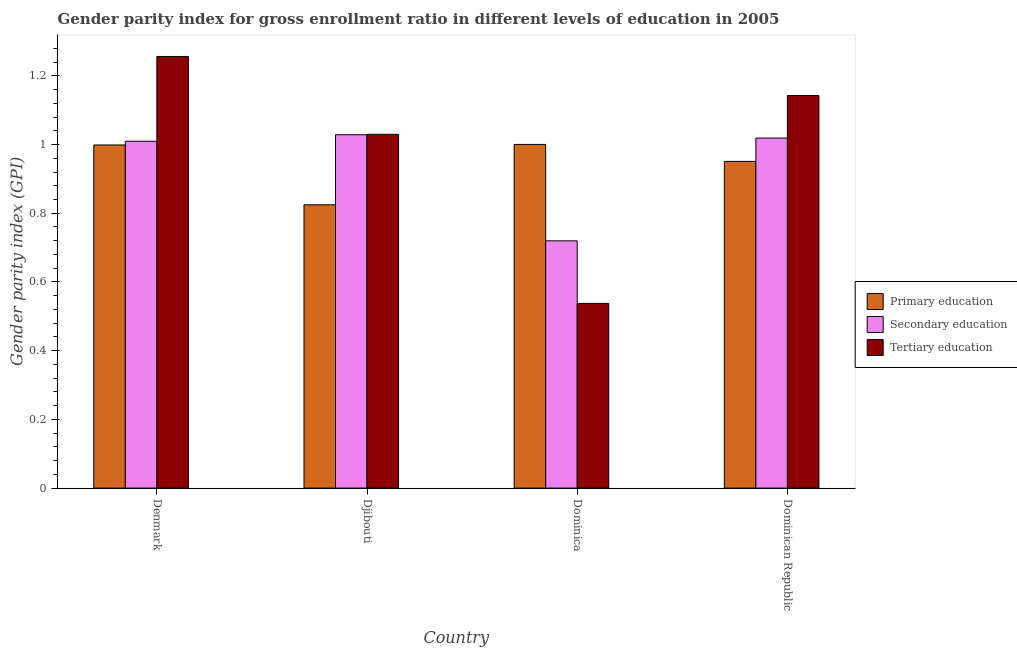How many different coloured bars are there?
Your response must be concise. 3. What is the label of the 3rd group of bars from the left?
Provide a short and direct response. Dominica. What is the gender parity index in tertiary education in Dominica?
Your answer should be very brief. 0.54. Across all countries, what is the maximum gender parity index in primary education?
Give a very brief answer. 1. Across all countries, what is the minimum gender parity index in secondary education?
Offer a terse response. 0.72. In which country was the gender parity index in tertiary education maximum?
Give a very brief answer. Denmark. In which country was the gender parity index in secondary education minimum?
Your answer should be compact. Dominica. What is the total gender parity index in tertiary education in the graph?
Offer a terse response. 3.97. What is the difference between the gender parity index in tertiary education in Dominica and that in Dominican Republic?
Keep it short and to the point. -0.61. What is the difference between the gender parity index in primary education in Djibouti and the gender parity index in tertiary education in Dominican Republic?
Ensure brevity in your answer.  -0.32. What is the average gender parity index in tertiary education per country?
Keep it short and to the point. 0.99. What is the difference between the gender parity index in primary education and gender parity index in tertiary education in Djibouti?
Keep it short and to the point. -0.21. What is the ratio of the gender parity index in primary education in Djibouti to that in Dominican Republic?
Offer a very short reply. 0.87. Is the gender parity index in primary education in Denmark less than that in Djibouti?
Your answer should be very brief. No. What is the difference between the highest and the second highest gender parity index in tertiary education?
Make the answer very short. 0.11. What is the difference between the highest and the lowest gender parity index in tertiary education?
Provide a succinct answer. 0.72. Is the sum of the gender parity index in primary education in Denmark and Djibouti greater than the maximum gender parity index in tertiary education across all countries?
Your answer should be very brief. Yes. What does the 1st bar from the left in Dominica represents?
Your answer should be compact. Primary education. Is it the case that in every country, the sum of the gender parity index in primary education and gender parity index in secondary education is greater than the gender parity index in tertiary education?
Your answer should be compact. Yes. Are all the bars in the graph horizontal?
Provide a succinct answer. No. How many countries are there in the graph?
Provide a succinct answer. 4. How are the legend labels stacked?
Provide a short and direct response. Vertical. What is the title of the graph?
Offer a terse response. Gender parity index for gross enrollment ratio in different levels of education in 2005. Does "Unpaid family workers" appear as one of the legend labels in the graph?
Your response must be concise. No. What is the label or title of the X-axis?
Your answer should be compact. Country. What is the label or title of the Y-axis?
Give a very brief answer. Gender parity index (GPI). What is the Gender parity index (GPI) of Primary education in Denmark?
Ensure brevity in your answer.  1. What is the Gender parity index (GPI) of Secondary education in Denmark?
Your answer should be very brief. 1.01. What is the Gender parity index (GPI) in Tertiary education in Denmark?
Your response must be concise. 1.26. What is the Gender parity index (GPI) in Primary education in Djibouti?
Your answer should be very brief. 0.82. What is the Gender parity index (GPI) of Secondary education in Djibouti?
Provide a short and direct response. 1.03. What is the Gender parity index (GPI) of Tertiary education in Djibouti?
Offer a terse response. 1.03. What is the Gender parity index (GPI) of Primary education in Dominica?
Keep it short and to the point. 1. What is the Gender parity index (GPI) of Secondary education in Dominica?
Keep it short and to the point. 0.72. What is the Gender parity index (GPI) in Tertiary education in Dominica?
Offer a very short reply. 0.54. What is the Gender parity index (GPI) of Primary education in Dominican Republic?
Make the answer very short. 0.95. What is the Gender parity index (GPI) of Secondary education in Dominican Republic?
Ensure brevity in your answer.  1.02. What is the Gender parity index (GPI) of Tertiary education in Dominican Republic?
Provide a succinct answer. 1.14. Across all countries, what is the maximum Gender parity index (GPI) in Primary education?
Offer a very short reply. 1. Across all countries, what is the maximum Gender parity index (GPI) in Secondary education?
Your answer should be compact. 1.03. Across all countries, what is the maximum Gender parity index (GPI) of Tertiary education?
Provide a succinct answer. 1.26. Across all countries, what is the minimum Gender parity index (GPI) of Primary education?
Provide a short and direct response. 0.82. Across all countries, what is the minimum Gender parity index (GPI) in Secondary education?
Make the answer very short. 0.72. Across all countries, what is the minimum Gender parity index (GPI) of Tertiary education?
Ensure brevity in your answer.  0.54. What is the total Gender parity index (GPI) in Primary education in the graph?
Provide a succinct answer. 3.77. What is the total Gender parity index (GPI) in Secondary education in the graph?
Keep it short and to the point. 3.78. What is the total Gender parity index (GPI) in Tertiary education in the graph?
Keep it short and to the point. 3.97. What is the difference between the Gender parity index (GPI) of Primary education in Denmark and that in Djibouti?
Ensure brevity in your answer.  0.17. What is the difference between the Gender parity index (GPI) of Secondary education in Denmark and that in Djibouti?
Your answer should be very brief. -0.02. What is the difference between the Gender parity index (GPI) of Tertiary education in Denmark and that in Djibouti?
Make the answer very short. 0.23. What is the difference between the Gender parity index (GPI) of Primary education in Denmark and that in Dominica?
Your response must be concise. -0. What is the difference between the Gender parity index (GPI) in Secondary education in Denmark and that in Dominica?
Ensure brevity in your answer.  0.29. What is the difference between the Gender parity index (GPI) of Tertiary education in Denmark and that in Dominica?
Give a very brief answer. 0.72. What is the difference between the Gender parity index (GPI) of Primary education in Denmark and that in Dominican Republic?
Your answer should be very brief. 0.05. What is the difference between the Gender parity index (GPI) of Secondary education in Denmark and that in Dominican Republic?
Give a very brief answer. -0.01. What is the difference between the Gender parity index (GPI) of Tertiary education in Denmark and that in Dominican Republic?
Ensure brevity in your answer.  0.11. What is the difference between the Gender parity index (GPI) in Primary education in Djibouti and that in Dominica?
Keep it short and to the point. -0.18. What is the difference between the Gender parity index (GPI) of Secondary education in Djibouti and that in Dominica?
Provide a succinct answer. 0.31. What is the difference between the Gender parity index (GPI) of Tertiary education in Djibouti and that in Dominica?
Offer a very short reply. 0.49. What is the difference between the Gender parity index (GPI) of Primary education in Djibouti and that in Dominican Republic?
Your response must be concise. -0.13. What is the difference between the Gender parity index (GPI) in Secondary education in Djibouti and that in Dominican Republic?
Make the answer very short. 0.01. What is the difference between the Gender parity index (GPI) in Tertiary education in Djibouti and that in Dominican Republic?
Provide a succinct answer. -0.11. What is the difference between the Gender parity index (GPI) in Primary education in Dominica and that in Dominican Republic?
Your answer should be compact. 0.05. What is the difference between the Gender parity index (GPI) of Secondary education in Dominica and that in Dominican Republic?
Provide a short and direct response. -0.3. What is the difference between the Gender parity index (GPI) in Tertiary education in Dominica and that in Dominican Republic?
Provide a succinct answer. -0.61. What is the difference between the Gender parity index (GPI) in Primary education in Denmark and the Gender parity index (GPI) in Secondary education in Djibouti?
Provide a succinct answer. -0.03. What is the difference between the Gender parity index (GPI) in Primary education in Denmark and the Gender parity index (GPI) in Tertiary education in Djibouti?
Ensure brevity in your answer.  -0.03. What is the difference between the Gender parity index (GPI) in Secondary education in Denmark and the Gender parity index (GPI) in Tertiary education in Djibouti?
Provide a short and direct response. -0.02. What is the difference between the Gender parity index (GPI) of Primary education in Denmark and the Gender parity index (GPI) of Secondary education in Dominica?
Provide a succinct answer. 0.28. What is the difference between the Gender parity index (GPI) in Primary education in Denmark and the Gender parity index (GPI) in Tertiary education in Dominica?
Provide a succinct answer. 0.46. What is the difference between the Gender parity index (GPI) in Secondary education in Denmark and the Gender parity index (GPI) in Tertiary education in Dominica?
Your answer should be very brief. 0.47. What is the difference between the Gender parity index (GPI) in Primary education in Denmark and the Gender parity index (GPI) in Secondary education in Dominican Republic?
Provide a succinct answer. -0.02. What is the difference between the Gender parity index (GPI) in Primary education in Denmark and the Gender parity index (GPI) in Tertiary education in Dominican Republic?
Make the answer very short. -0.14. What is the difference between the Gender parity index (GPI) in Secondary education in Denmark and the Gender parity index (GPI) in Tertiary education in Dominican Republic?
Your answer should be compact. -0.13. What is the difference between the Gender parity index (GPI) of Primary education in Djibouti and the Gender parity index (GPI) of Secondary education in Dominica?
Your answer should be compact. 0.1. What is the difference between the Gender parity index (GPI) in Primary education in Djibouti and the Gender parity index (GPI) in Tertiary education in Dominica?
Offer a very short reply. 0.29. What is the difference between the Gender parity index (GPI) of Secondary education in Djibouti and the Gender parity index (GPI) of Tertiary education in Dominica?
Your answer should be compact. 0.49. What is the difference between the Gender parity index (GPI) in Primary education in Djibouti and the Gender parity index (GPI) in Secondary education in Dominican Republic?
Keep it short and to the point. -0.19. What is the difference between the Gender parity index (GPI) in Primary education in Djibouti and the Gender parity index (GPI) in Tertiary education in Dominican Republic?
Offer a terse response. -0.32. What is the difference between the Gender parity index (GPI) of Secondary education in Djibouti and the Gender parity index (GPI) of Tertiary education in Dominican Republic?
Offer a terse response. -0.11. What is the difference between the Gender parity index (GPI) in Primary education in Dominica and the Gender parity index (GPI) in Secondary education in Dominican Republic?
Give a very brief answer. -0.02. What is the difference between the Gender parity index (GPI) of Primary education in Dominica and the Gender parity index (GPI) of Tertiary education in Dominican Republic?
Your answer should be compact. -0.14. What is the difference between the Gender parity index (GPI) in Secondary education in Dominica and the Gender parity index (GPI) in Tertiary education in Dominican Republic?
Give a very brief answer. -0.42. What is the average Gender parity index (GPI) of Primary education per country?
Offer a very short reply. 0.94. What is the average Gender parity index (GPI) in Secondary education per country?
Your response must be concise. 0.94. What is the average Gender parity index (GPI) in Tertiary education per country?
Give a very brief answer. 0.99. What is the difference between the Gender parity index (GPI) of Primary education and Gender parity index (GPI) of Secondary education in Denmark?
Give a very brief answer. -0.01. What is the difference between the Gender parity index (GPI) in Primary education and Gender parity index (GPI) in Tertiary education in Denmark?
Offer a very short reply. -0.26. What is the difference between the Gender parity index (GPI) in Secondary education and Gender parity index (GPI) in Tertiary education in Denmark?
Give a very brief answer. -0.25. What is the difference between the Gender parity index (GPI) in Primary education and Gender parity index (GPI) in Secondary education in Djibouti?
Offer a very short reply. -0.2. What is the difference between the Gender parity index (GPI) of Primary education and Gender parity index (GPI) of Tertiary education in Djibouti?
Your response must be concise. -0.21. What is the difference between the Gender parity index (GPI) in Secondary education and Gender parity index (GPI) in Tertiary education in Djibouti?
Provide a succinct answer. -0. What is the difference between the Gender parity index (GPI) in Primary education and Gender parity index (GPI) in Secondary education in Dominica?
Ensure brevity in your answer.  0.28. What is the difference between the Gender parity index (GPI) of Primary education and Gender parity index (GPI) of Tertiary education in Dominica?
Your answer should be very brief. 0.46. What is the difference between the Gender parity index (GPI) of Secondary education and Gender parity index (GPI) of Tertiary education in Dominica?
Keep it short and to the point. 0.18. What is the difference between the Gender parity index (GPI) in Primary education and Gender parity index (GPI) in Secondary education in Dominican Republic?
Your response must be concise. -0.07. What is the difference between the Gender parity index (GPI) in Primary education and Gender parity index (GPI) in Tertiary education in Dominican Republic?
Provide a short and direct response. -0.19. What is the difference between the Gender parity index (GPI) in Secondary education and Gender parity index (GPI) in Tertiary education in Dominican Republic?
Offer a terse response. -0.12. What is the ratio of the Gender parity index (GPI) in Primary education in Denmark to that in Djibouti?
Ensure brevity in your answer.  1.21. What is the ratio of the Gender parity index (GPI) in Secondary education in Denmark to that in Djibouti?
Offer a very short reply. 0.98. What is the ratio of the Gender parity index (GPI) in Tertiary education in Denmark to that in Djibouti?
Make the answer very short. 1.22. What is the ratio of the Gender parity index (GPI) of Primary education in Denmark to that in Dominica?
Provide a short and direct response. 1. What is the ratio of the Gender parity index (GPI) in Secondary education in Denmark to that in Dominica?
Make the answer very short. 1.4. What is the ratio of the Gender parity index (GPI) of Tertiary education in Denmark to that in Dominica?
Your answer should be compact. 2.34. What is the ratio of the Gender parity index (GPI) in Primary education in Denmark to that in Dominican Republic?
Make the answer very short. 1.05. What is the ratio of the Gender parity index (GPI) of Secondary education in Denmark to that in Dominican Republic?
Your response must be concise. 0.99. What is the ratio of the Gender parity index (GPI) of Tertiary education in Denmark to that in Dominican Republic?
Provide a short and direct response. 1.1. What is the ratio of the Gender parity index (GPI) in Primary education in Djibouti to that in Dominica?
Your response must be concise. 0.82. What is the ratio of the Gender parity index (GPI) of Secondary education in Djibouti to that in Dominica?
Ensure brevity in your answer.  1.43. What is the ratio of the Gender parity index (GPI) in Tertiary education in Djibouti to that in Dominica?
Give a very brief answer. 1.92. What is the ratio of the Gender parity index (GPI) of Primary education in Djibouti to that in Dominican Republic?
Make the answer very short. 0.87. What is the ratio of the Gender parity index (GPI) of Secondary education in Djibouti to that in Dominican Republic?
Provide a short and direct response. 1.01. What is the ratio of the Gender parity index (GPI) of Tertiary education in Djibouti to that in Dominican Republic?
Offer a terse response. 0.9. What is the ratio of the Gender parity index (GPI) in Primary education in Dominica to that in Dominican Republic?
Your answer should be compact. 1.05. What is the ratio of the Gender parity index (GPI) in Secondary education in Dominica to that in Dominican Republic?
Give a very brief answer. 0.71. What is the ratio of the Gender parity index (GPI) of Tertiary education in Dominica to that in Dominican Republic?
Offer a terse response. 0.47. What is the difference between the highest and the second highest Gender parity index (GPI) of Primary education?
Provide a short and direct response. 0. What is the difference between the highest and the second highest Gender parity index (GPI) in Secondary education?
Your response must be concise. 0.01. What is the difference between the highest and the second highest Gender parity index (GPI) of Tertiary education?
Ensure brevity in your answer.  0.11. What is the difference between the highest and the lowest Gender parity index (GPI) of Primary education?
Make the answer very short. 0.18. What is the difference between the highest and the lowest Gender parity index (GPI) in Secondary education?
Your response must be concise. 0.31. What is the difference between the highest and the lowest Gender parity index (GPI) of Tertiary education?
Offer a terse response. 0.72. 